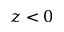<formula> <loc_0><loc_0><loc_500><loc_500>z < 0</formula> 